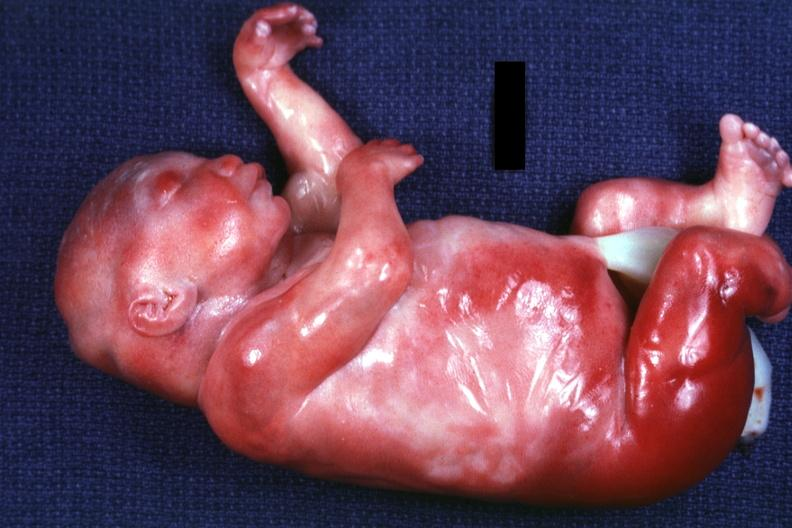s polycystic disease of kidneys present?
Answer the question using a single word or phrase. Yes 